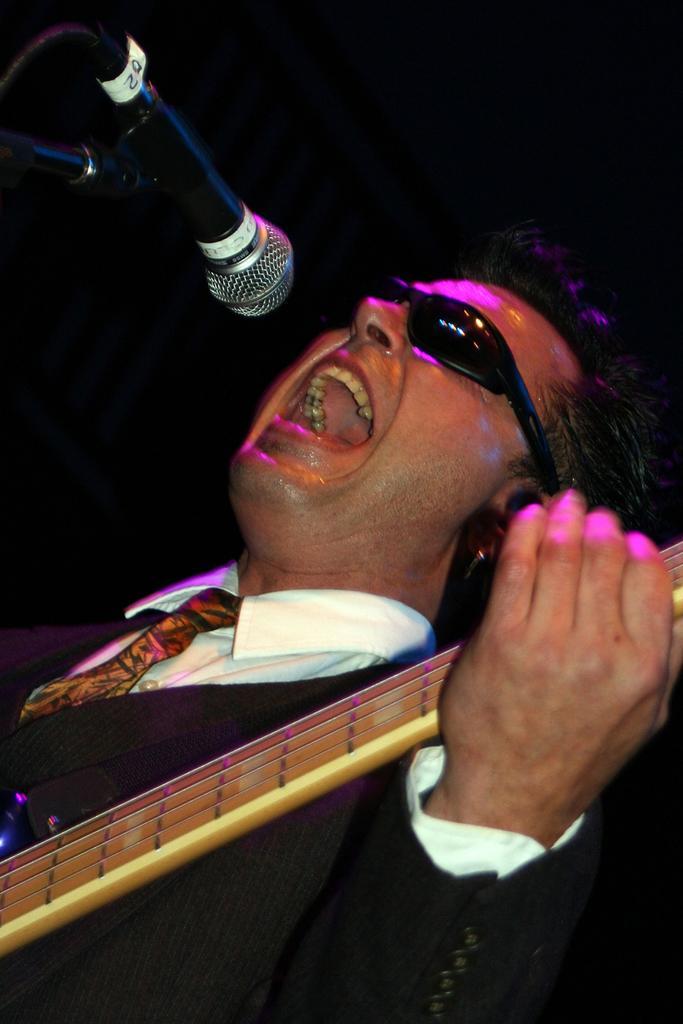Please provide a concise description of this image. In this image i can see a person wearing a white shirt and black blazer holding a guitar in his hand, he is wearing black sun glasses. I can see a microphone in front of him. 